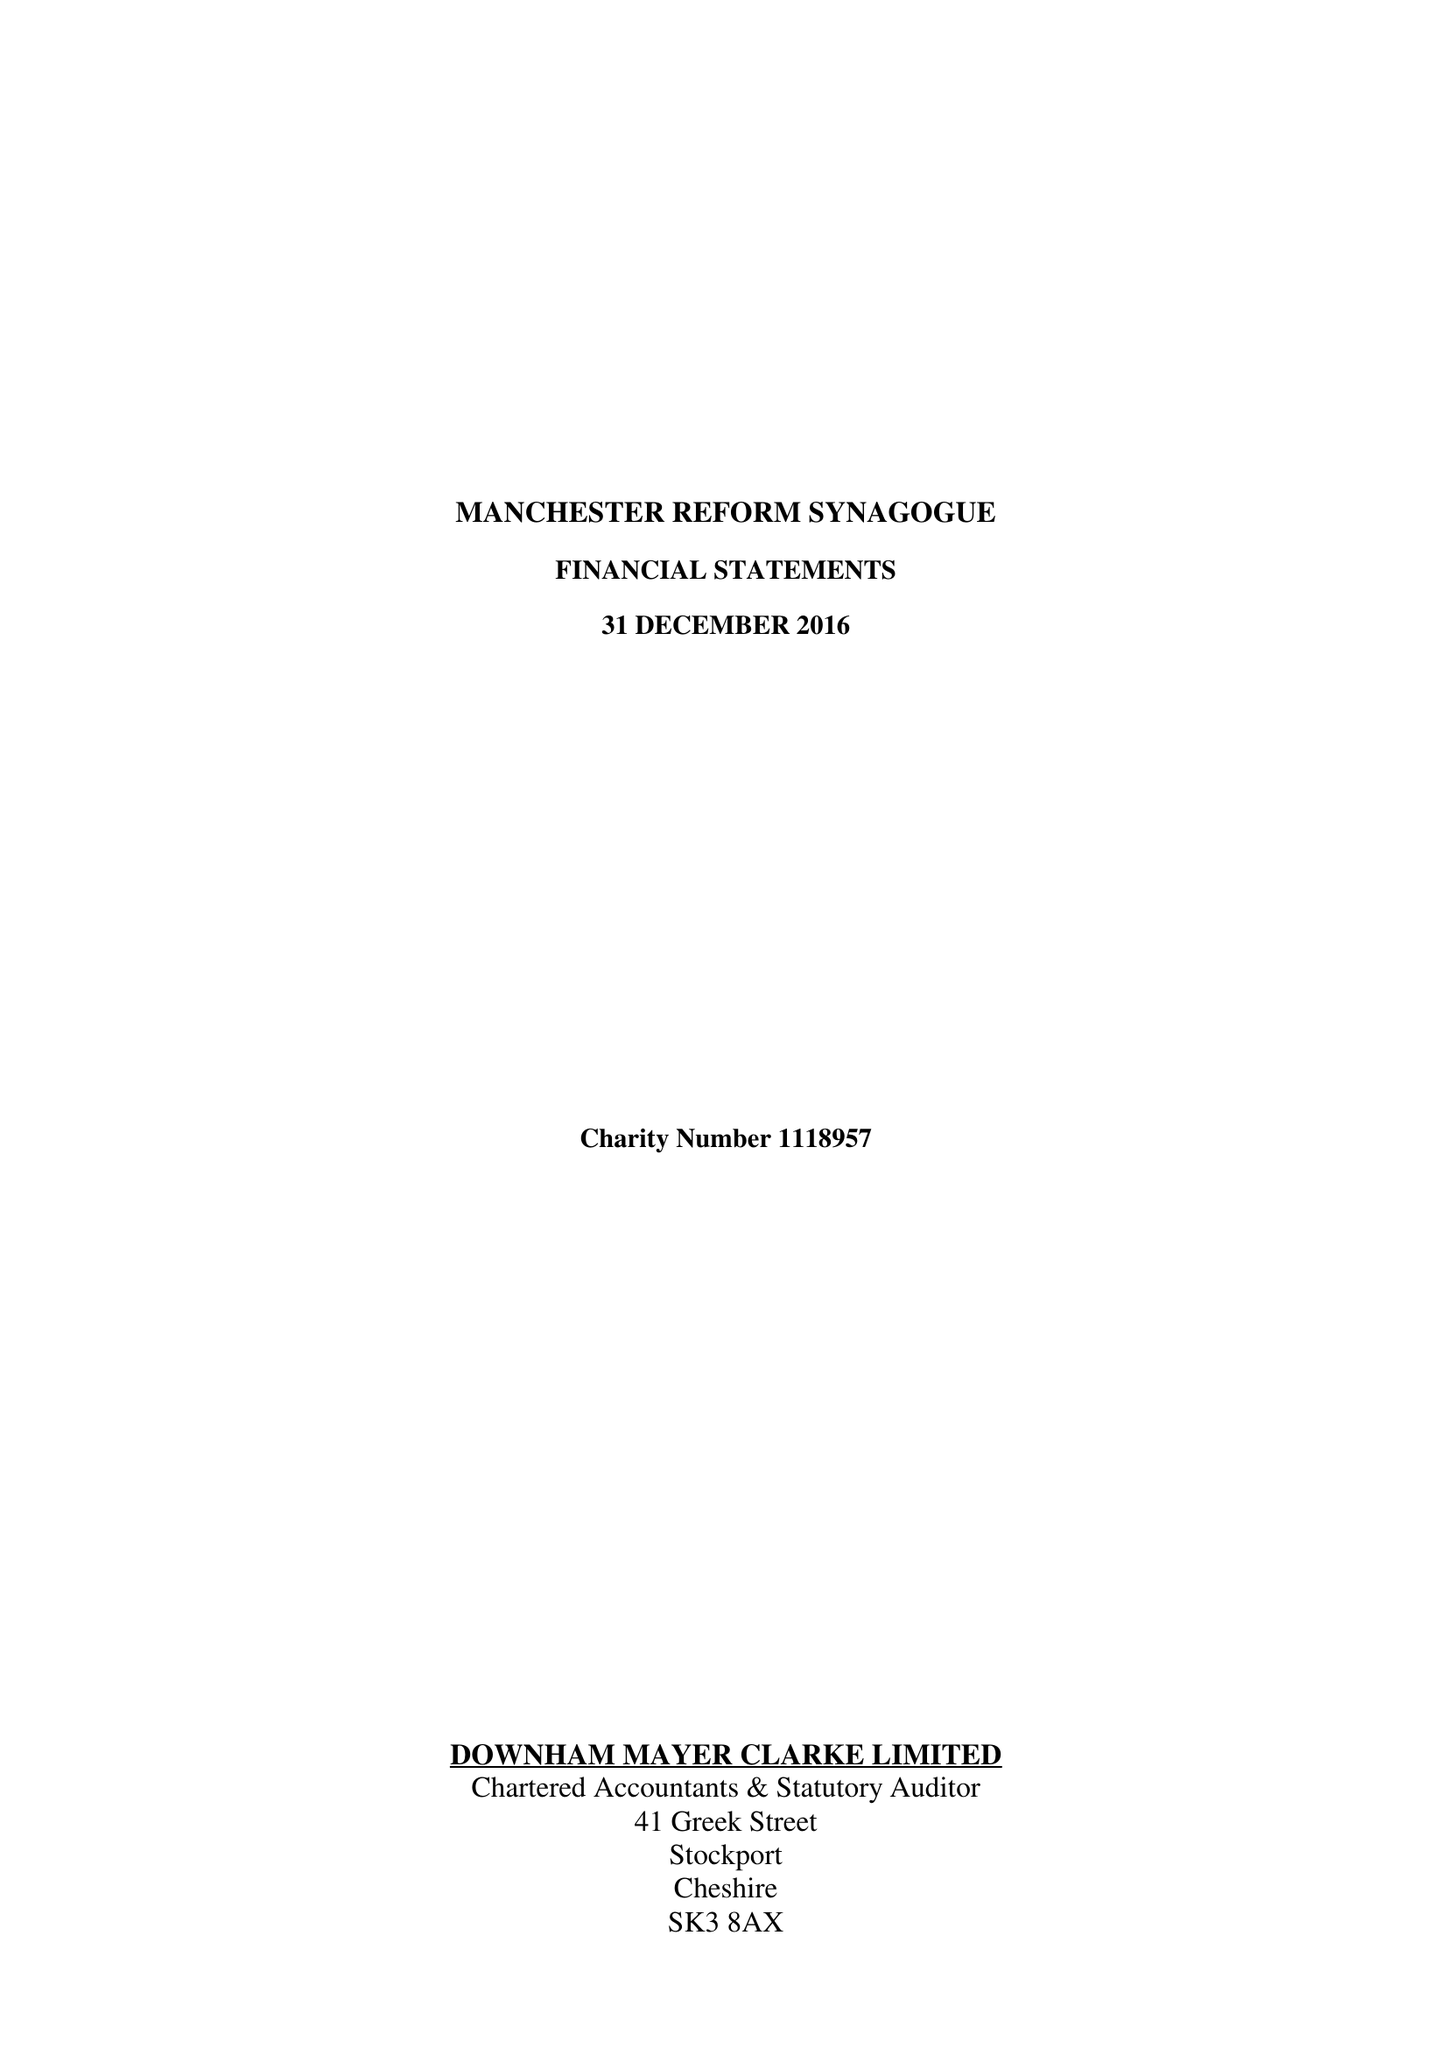What is the value for the report_date?
Answer the question using a single word or phrase. 2016-12-31 